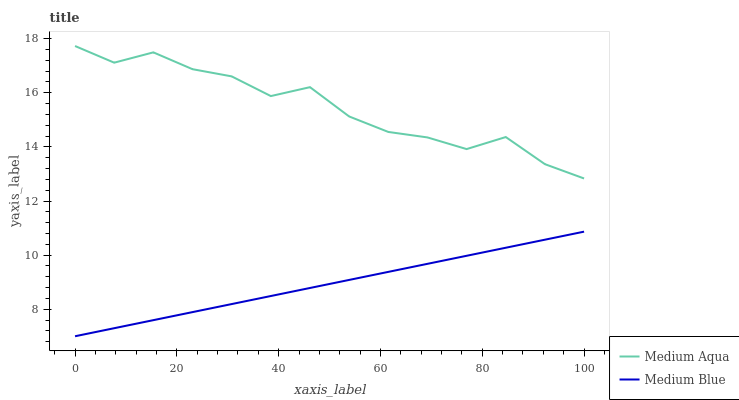Does Medium Blue have the minimum area under the curve?
Answer yes or no. Yes. Does Medium Aqua have the maximum area under the curve?
Answer yes or no. Yes. Does Medium Aqua have the minimum area under the curve?
Answer yes or no. No. Is Medium Blue the smoothest?
Answer yes or no. Yes. Is Medium Aqua the roughest?
Answer yes or no. Yes. Is Medium Aqua the smoothest?
Answer yes or no. No. Does Medium Blue have the lowest value?
Answer yes or no. Yes. Does Medium Aqua have the lowest value?
Answer yes or no. No. Does Medium Aqua have the highest value?
Answer yes or no. Yes. Is Medium Blue less than Medium Aqua?
Answer yes or no. Yes. Is Medium Aqua greater than Medium Blue?
Answer yes or no. Yes. Does Medium Blue intersect Medium Aqua?
Answer yes or no. No. 